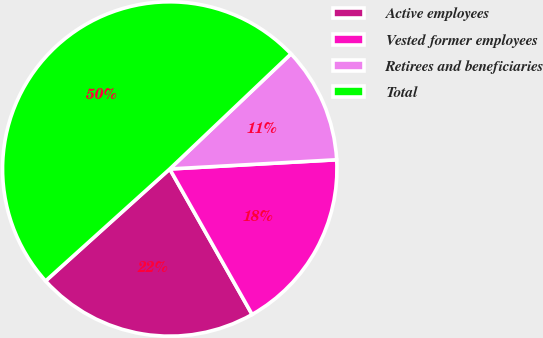Convert chart. <chart><loc_0><loc_0><loc_500><loc_500><pie_chart><fcel>Active employees<fcel>Vested former employees<fcel>Retirees and beneficiaries<fcel>Total<nl><fcel>21.52%<fcel>17.68%<fcel>11.21%<fcel>49.59%<nl></chart> 